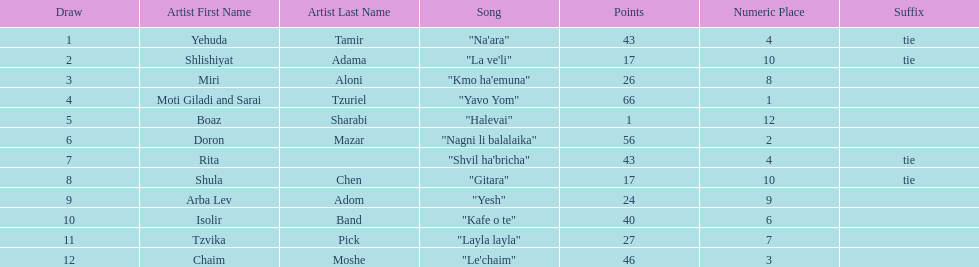What are the number of times an artist earned first place? 1. 